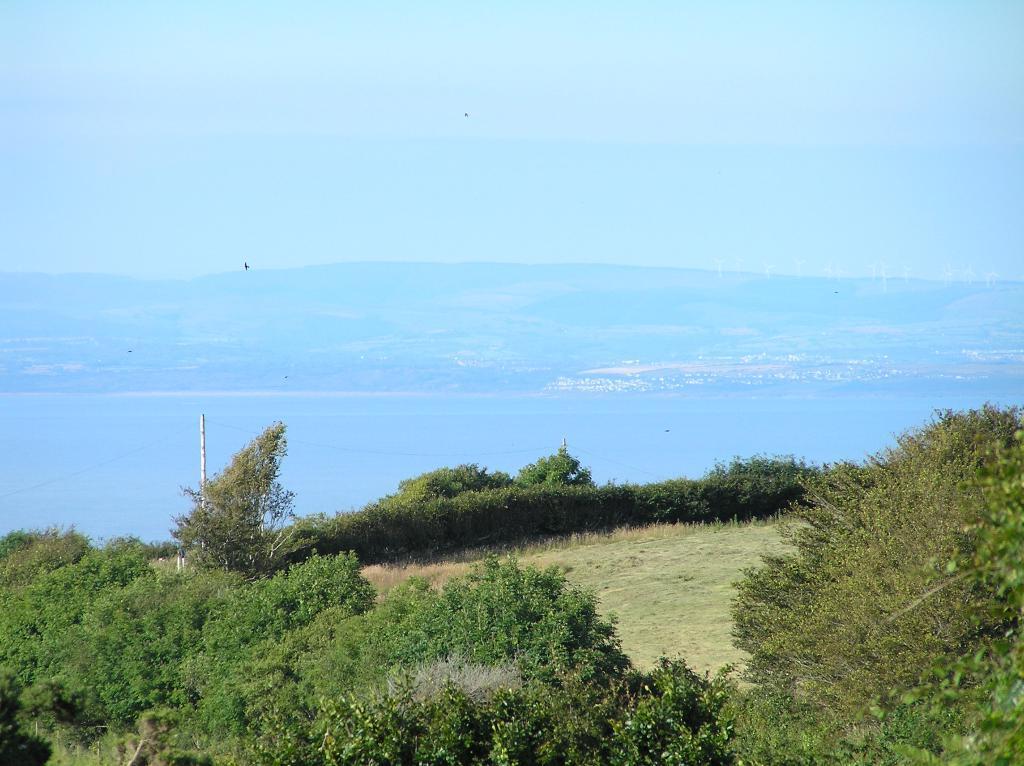In one or two sentences, can you explain what this image depicts? In this image we can see some trees and grass on the ground and in the middle of the picture we can see the water and some mountains in the background. At the top, we can see the sky. 